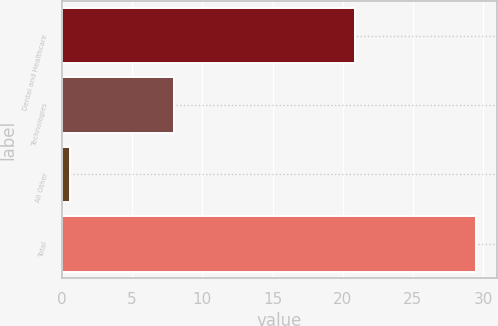<chart> <loc_0><loc_0><loc_500><loc_500><bar_chart><fcel>Dental and Healthcare<fcel>Technologies<fcel>All Other<fcel>Total<nl><fcel>20.9<fcel>8<fcel>0.6<fcel>29.5<nl></chart> 